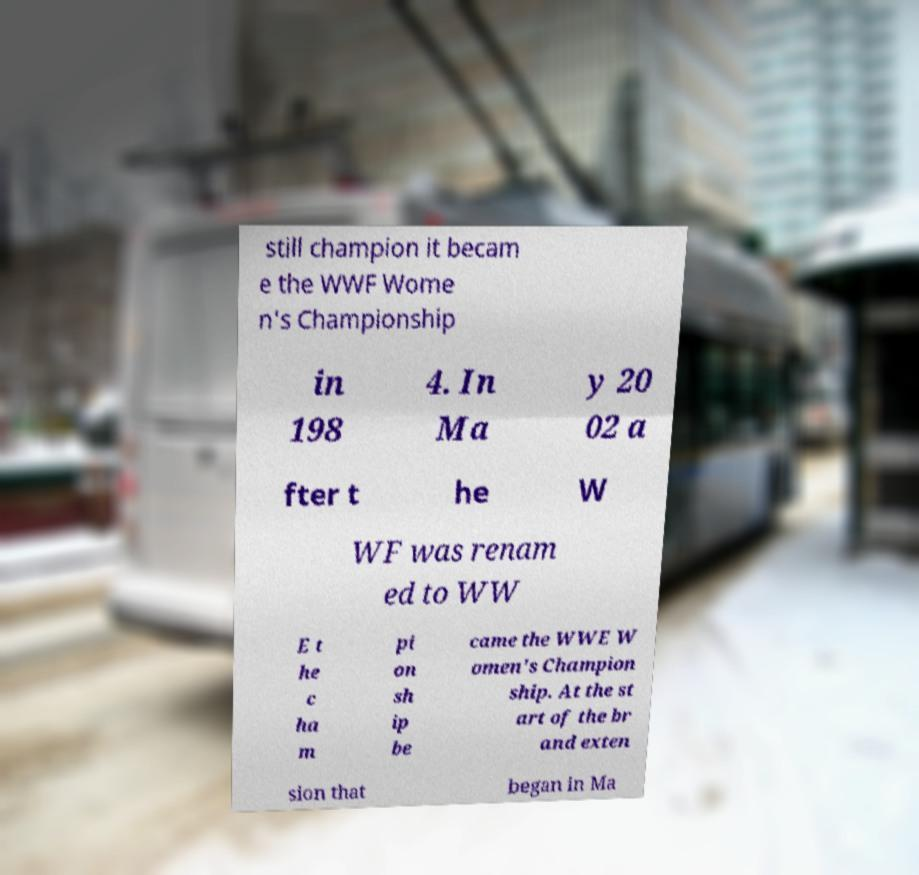For documentation purposes, I need the text within this image transcribed. Could you provide that? still champion it becam e the WWF Wome n's Championship in 198 4. In Ma y 20 02 a fter t he W WF was renam ed to WW E t he c ha m pi on sh ip be came the WWE W omen's Champion ship. At the st art of the br and exten sion that began in Ma 